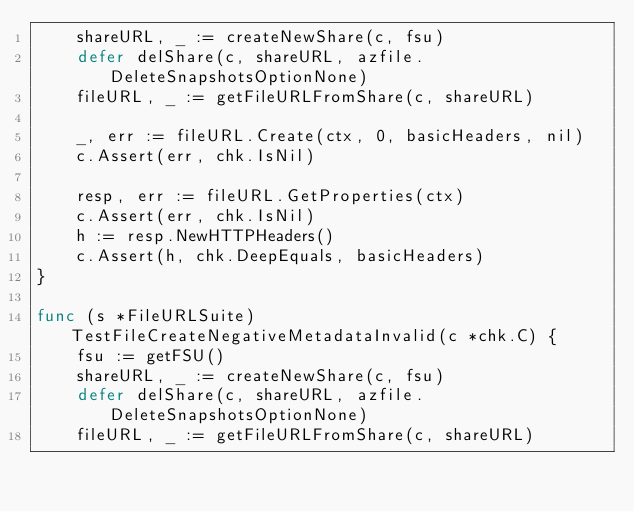<code> <loc_0><loc_0><loc_500><loc_500><_Go_>	shareURL, _ := createNewShare(c, fsu)
	defer delShare(c, shareURL, azfile.DeleteSnapshotsOptionNone)
	fileURL, _ := getFileURLFromShare(c, shareURL)

	_, err := fileURL.Create(ctx, 0, basicHeaders, nil)
	c.Assert(err, chk.IsNil)

	resp, err := fileURL.GetProperties(ctx)
	c.Assert(err, chk.IsNil)
	h := resp.NewHTTPHeaders()
	c.Assert(h, chk.DeepEquals, basicHeaders)
}

func (s *FileURLSuite) TestFileCreateNegativeMetadataInvalid(c *chk.C) {
	fsu := getFSU()
	shareURL, _ := createNewShare(c, fsu)
	defer delShare(c, shareURL, azfile.DeleteSnapshotsOptionNone)
	fileURL, _ := getFileURLFromShare(c, shareURL)
</code> 